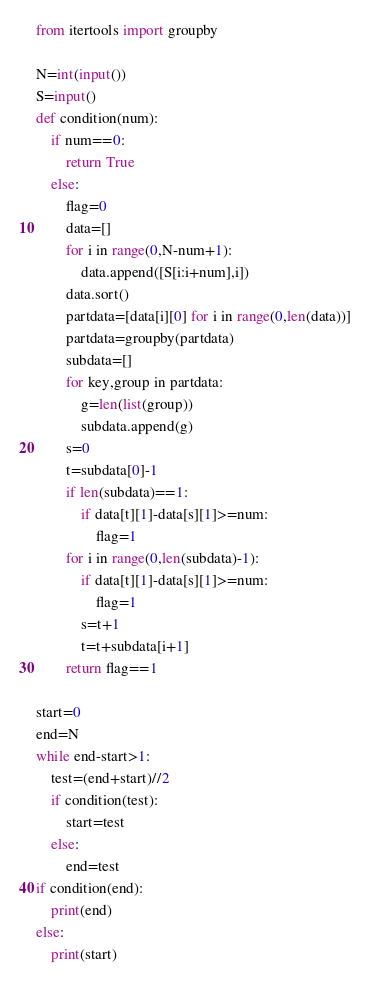<code> <loc_0><loc_0><loc_500><loc_500><_Python_>from itertools import groupby

N=int(input())
S=input()
def condition(num):
    if num==0:
        return True
    else:
        flag=0
        data=[]
        for i in range(0,N-num+1):
            data.append([S[i:i+num],i])
        data.sort()
        partdata=[data[i][0] for i in range(0,len(data))]
        partdata=groupby(partdata)
        subdata=[]
        for key,group in partdata:
            g=len(list(group))
            subdata.append(g)
        s=0
        t=subdata[0]-1
        if len(subdata)==1:
            if data[t][1]-data[s][1]>=num:
                flag=1
        for i in range(0,len(subdata)-1):
            if data[t][1]-data[s][1]>=num:
                flag=1
            s=t+1
            t=t+subdata[i+1]
        return flag==1

start=0
end=N
while end-start>1:
    test=(end+start)//2
    if condition(test):
        start=test
    else:
        end=test
if condition(end):
    print(end)
else:
    print(start)</code> 